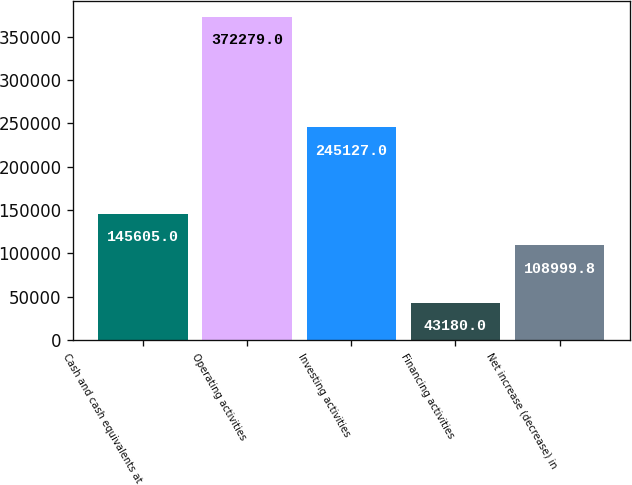Convert chart to OTSL. <chart><loc_0><loc_0><loc_500><loc_500><bar_chart><fcel>Cash and cash equivalents at<fcel>Operating activities<fcel>Investing activities<fcel>Financing activities<fcel>Net increase (decrease) in<nl><fcel>145605<fcel>372279<fcel>245127<fcel>43180<fcel>109000<nl></chart> 